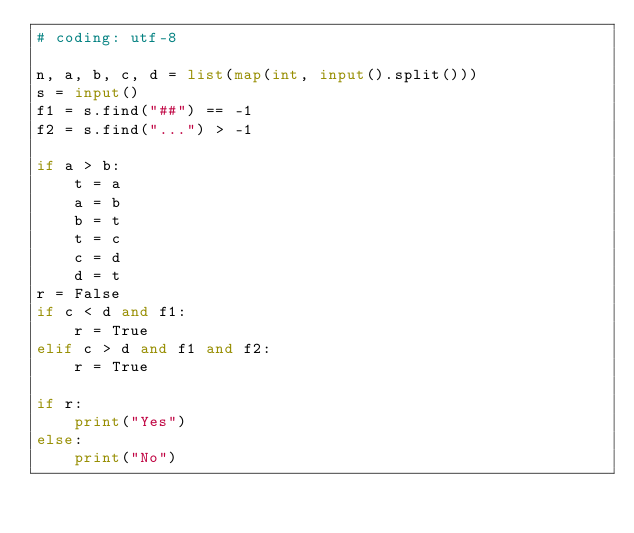Convert code to text. <code><loc_0><loc_0><loc_500><loc_500><_Python_># coding: utf-8

n, a, b, c, d = list(map(int, input().split()))
s = input()
f1 = s.find("##") == -1
f2 = s.find("...") > -1

if a > b:
    t = a
    a = b
    b = t
    t = c
    c = d
    d = t
r = False
if c < d and f1:
    r = True
elif c > d and f1 and f2:
    r = True

if r:
    print("Yes")
else:
    print("No")
</code> 